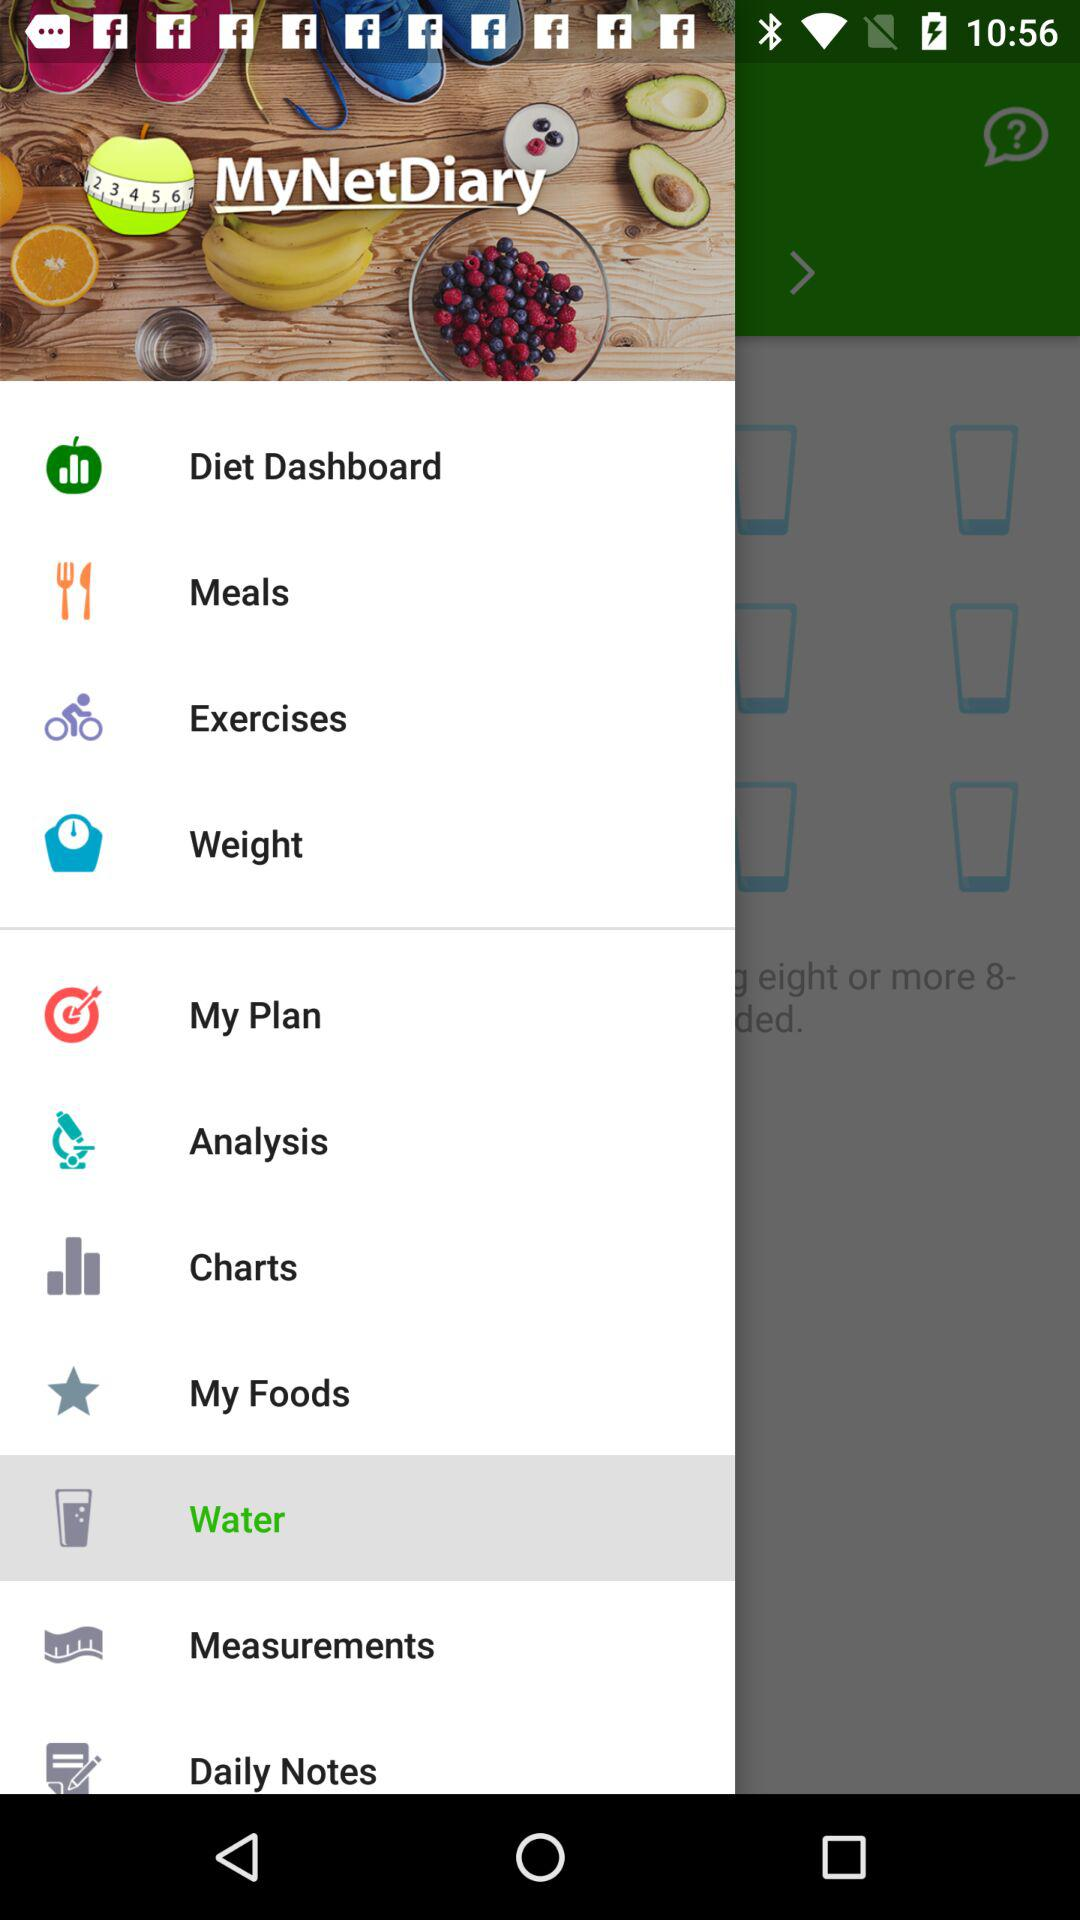What are the options available in the list? The available options are: "Diet Dashboard", "Meals", "Exercises", "Weight", "My Plan", "Analysis", "Charts", "My Foods", "Water", "Measurements", and "Daily Notes". 